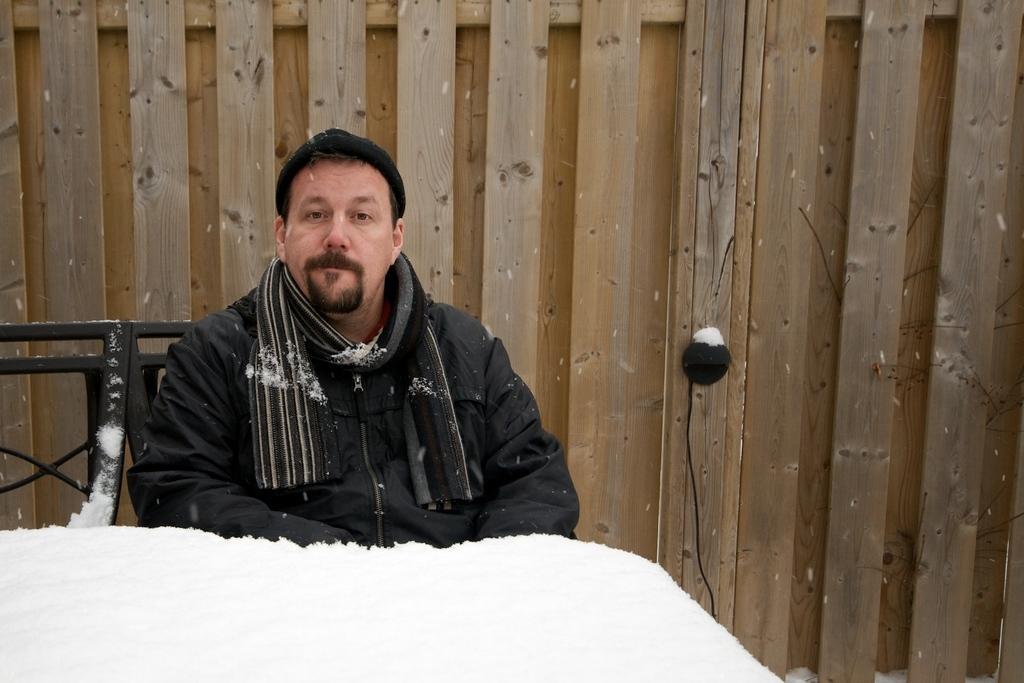Describe this image in one or two sentences. In the center of the image we can see a person is sitting on one of the attached chairs. In front of him, we can see snow. In the background there is a wooden wall and one black color object. 